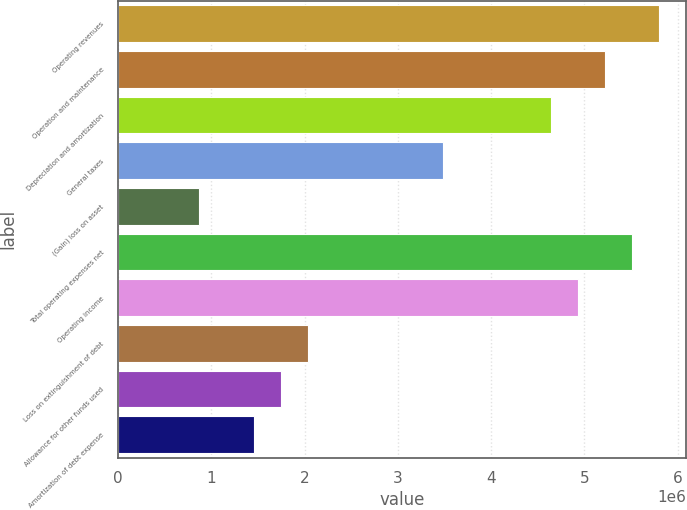<chart> <loc_0><loc_0><loc_500><loc_500><bar_chart><fcel>Operating revenues<fcel>Operation and maintenance<fcel>Depreciation and amortization<fcel>General taxes<fcel>(Gain) loss on asset<fcel>Total operating expenses net<fcel>Operating income<fcel>Loss on extinguishment of debt<fcel>Allowance for other funds used<fcel>Amortization of debt expense<nl><fcel>5.80371e+06<fcel>5.22334e+06<fcel>4.64297e+06<fcel>3.48223e+06<fcel>870558<fcel>5.51353e+06<fcel>4.93316e+06<fcel>2.0313e+06<fcel>1.74112e+06<fcel>1.45093e+06<nl></chart> 